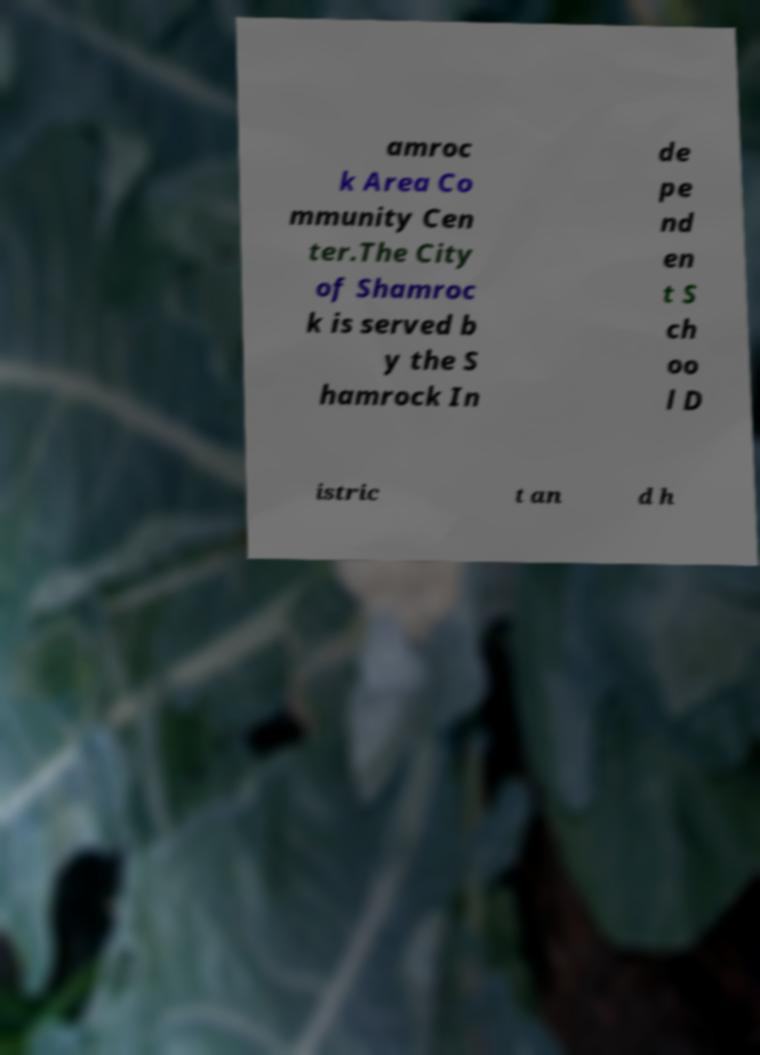Please read and relay the text visible in this image. What does it say? amroc k Area Co mmunity Cen ter.The City of Shamroc k is served b y the S hamrock In de pe nd en t S ch oo l D istric t an d h 